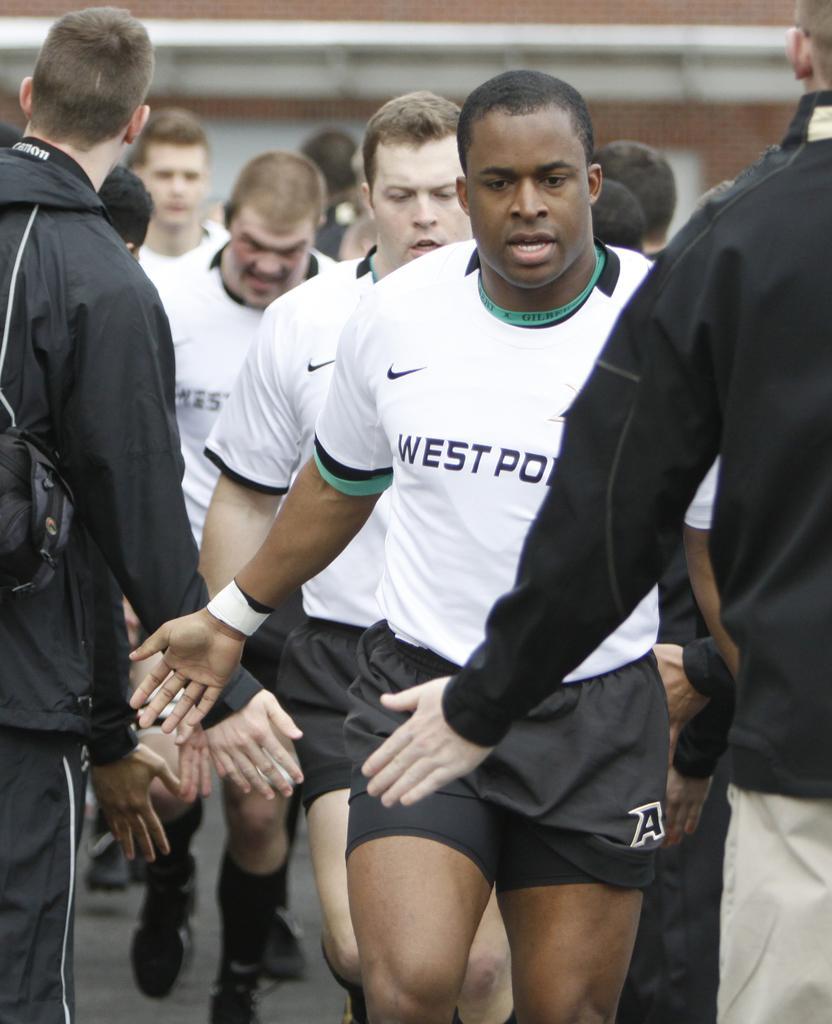Describe this image in one or two sentences. This picture shows few people walking and few are standing and clapping their hands to each other. 